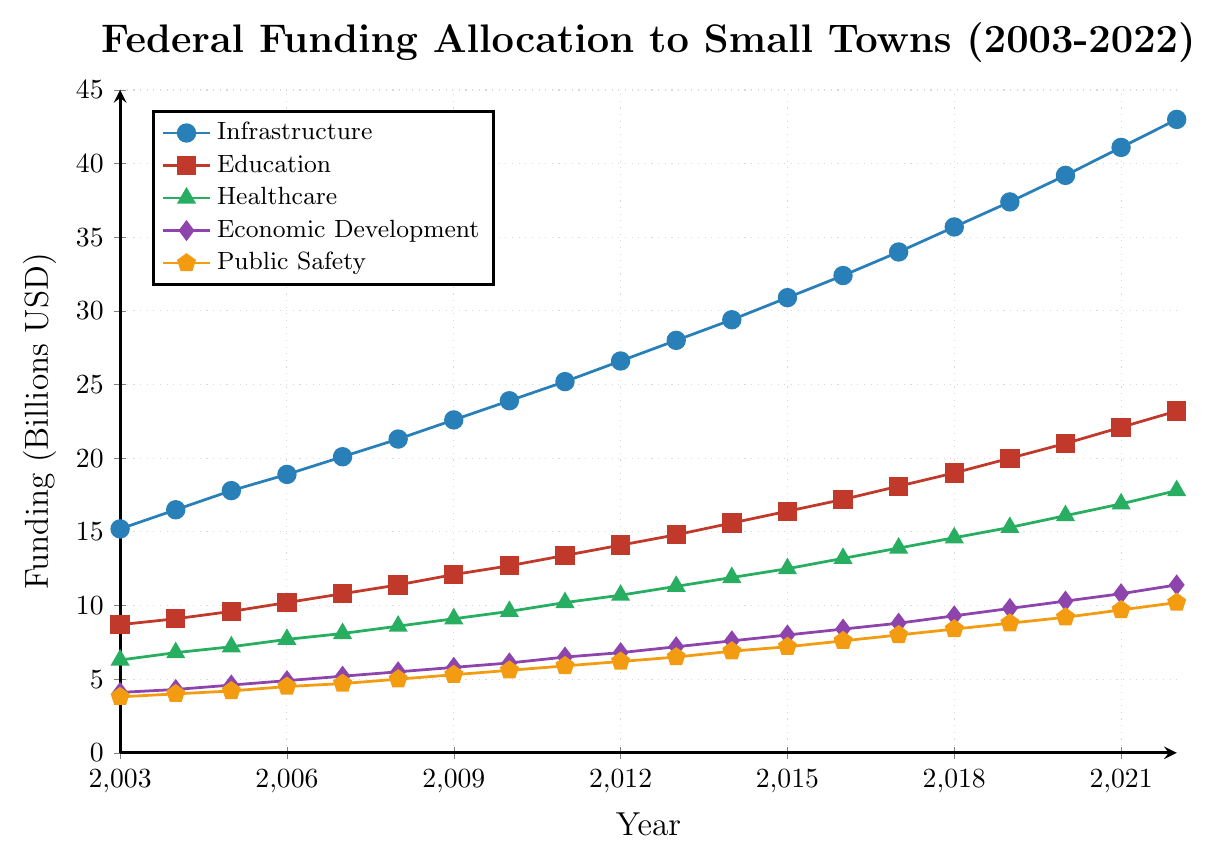What is the total funding allocated to Infrastructure and Education in 2010? In 2010, the funding for Infrastructure is 23.9 billion USD and for Education is 12.7 billion USD. The total is 23.9 + 12.7 = 36.6 billion USD.
Answer: 36.6 billion USD Which program had the highest funding in 2022? By examining the values in 2022, Infrastructure has the highest funding with 43.0 billion USD.
Answer: Infrastructure What is the average funding for Healthcare between 2003 and 2022? The sum of Healthcare funding values from 2003 to 2022 is 243.6 billion USD divided by 20 years (the number of data points), which gives 243.6 / 20 = 12.18 billion USD.
Answer: 12.18 billion USD How much did Public Safety funding increase from 2010 to 2020? In 2010, Public Safety funding was 5.6 billion USD, and in 2020, it was 9.2 billion USD. The increase is 9.2 - 5.6 = 3.6 billion USD.
Answer: 3.6 billion USD Which program had the slowest increase in funding from 2003 to 2022? By calculating the difference for each program from 2003 to 2022, Public Safety funding increased by the least amount (10.2 - 3.8 = 6.4 billion USD).
Answer: Public Safety In which year did Education funding surpass 15 billion USD? Education funding exceeded 15 billion USD in 2014 when it reached 15.6 billion USD.
Answer: 2014 Between 2009 and 2019, in which year did Infrastructure funding see the largest annual increase? By comparing the annual increases for Infrastructure funding between 2009 and 2019, the largest increase occurred in 2018 (35.7 - 34.0 = 1.7 billion USD).
Answer: 2018 What is the difference between the maximum funding allocated to Economic Development and the minimum funding allocated to the same program over the years? The maximum funding for Economic Development is 11.4 billion USD in 2022 and the minimum is 4.1 billion USD in 2003. The difference is 11.4 - 4.1 = 7.3 billion USD.
Answer: 7.3 billion USD In 2015, which two program categories had the closest funding amounts? In 2015, Healthcare had 12.5 billion USD, and Education had 16.4 billion USD. The closest funding amounts were for Economic Development (8.0 billion USD) and Public Safety (7.2 billion USD) with a difference of 0.8 billion USD between them.
Answer: Economic Development and Public Safety What is the funding trend for Healthcare from 2008 to 2012? The funding for Healthcare from 2008 to 2012 shows a consistent annual increase: 8.6 (2008), 9.1 (2009), 9.6 (2010), 10.2 (2011), 10.7 (2012).
Answer: Increasing trend 